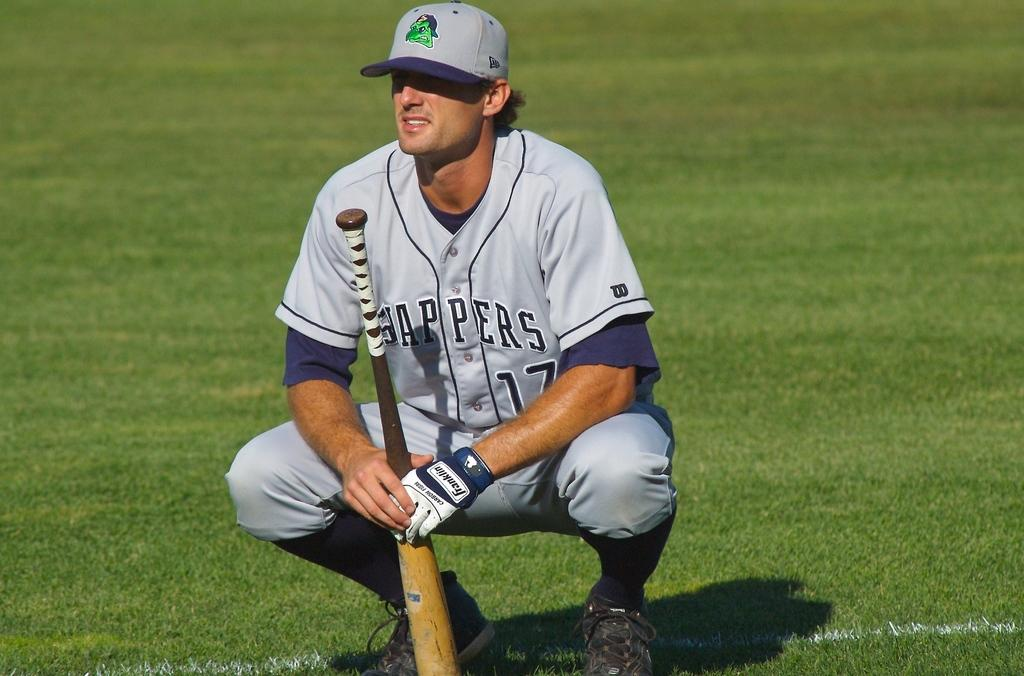<image>
Offer a succinct explanation of the picture presented. Player number 17 has a Franklin batting glove on one hand. 